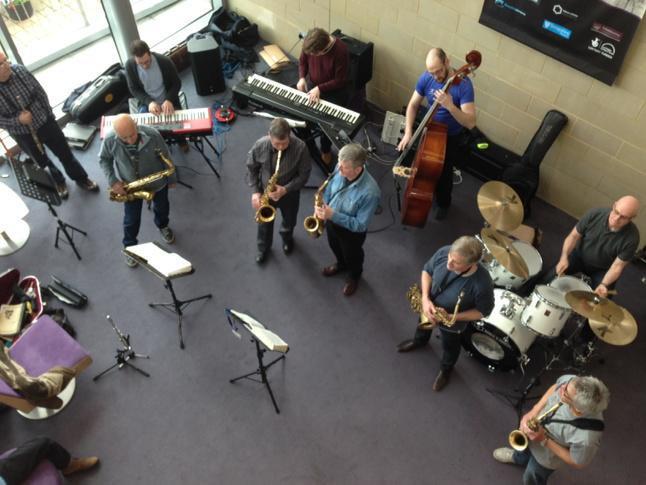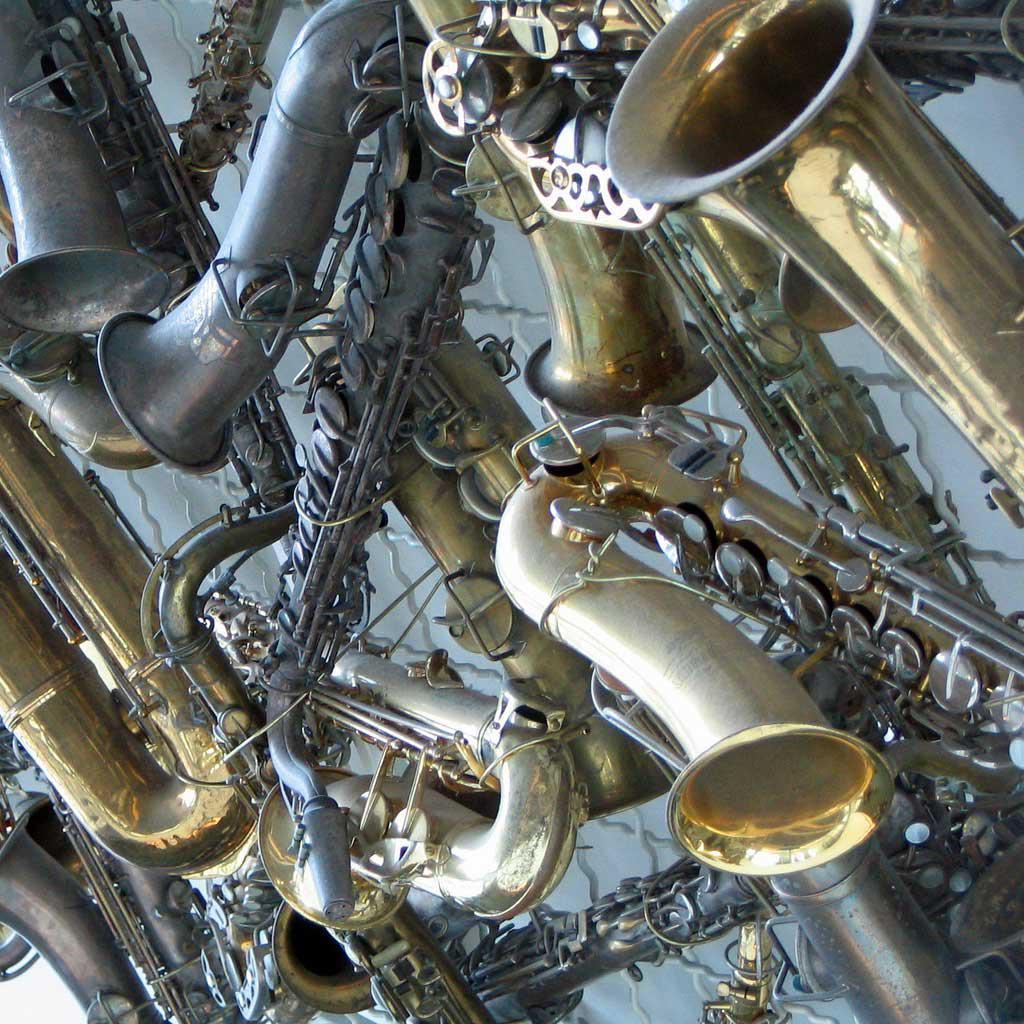The first image is the image on the left, the second image is the image on the right. For the images displayed, is the sentence "A saxophone is sitting on a black stand in the image on the right." factually correct? Answer yes or no. No. The first image is the image on the left, the second image is the image on the right. For the images shown, is this caption "At least four musicians hold saxophones in one image." true? Answer yes or no. Yes. 